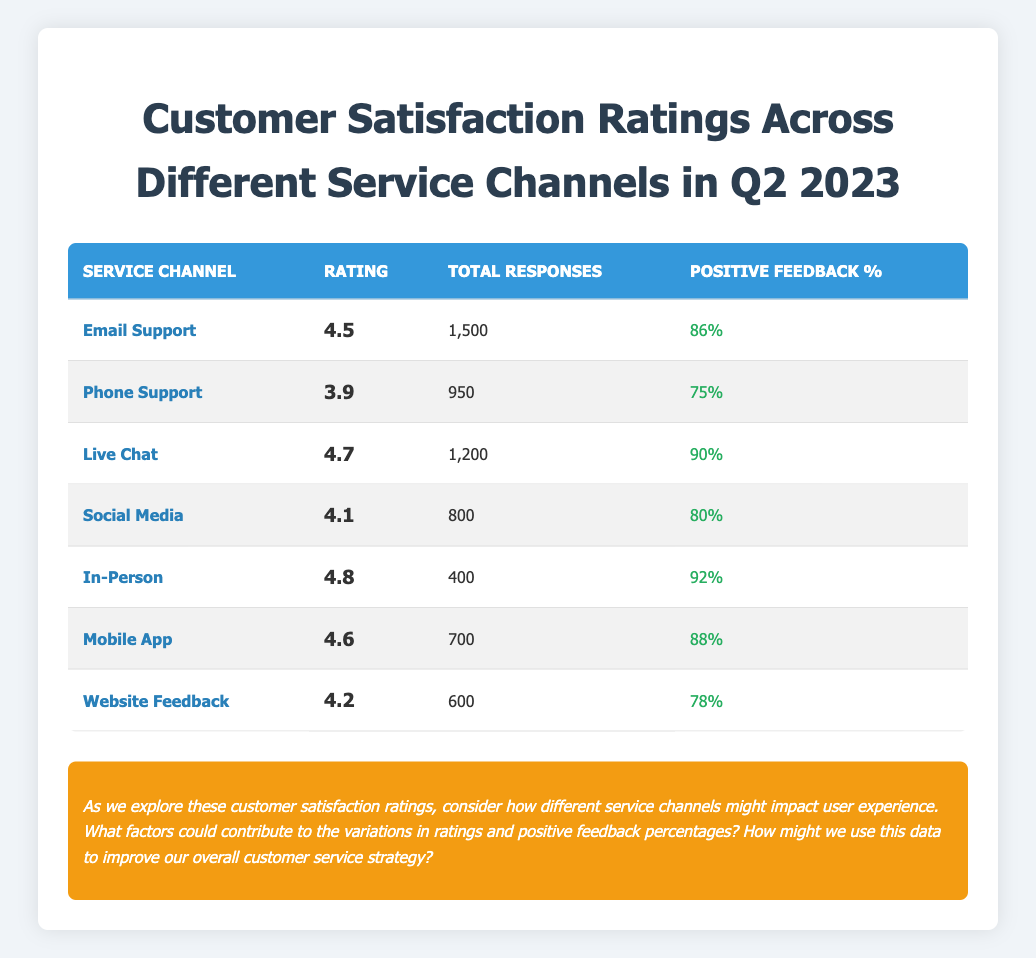What is the highest customer satisfaction rating among the service channels? The service channels and their ratings are listed in the table. The ratings are: 4.5 (Email Support), 3.9 (Phone Support), 4.7 (Live Chat), 4.1 (Social Media), 4.8 (In-Person), 4.6 (Mobile App), and 4.2 (Website Feedback). The highest among these is 4.8 for In-Person.
Answer: 4.8 How many total responses did Live Chat receive? The table shows that Live Chat had a total of 1,200 responses listed under the corresponding column.
Answer: 1,200 Which service channel has the lowest positive feedback percentage? The table shows the positive feedback percentages for each channel: 86% (Email Support), 75% (Phone Support), 90% (Live Chat), 80% (Social Media), 92% (In-Person), 88% (Mobile App), and 78% (Website Feedback). The lowest is 75% for Phone Support.
Answer: Phone Support What is the average rating for all service channels combined? To find the average rating, we sum the ratings (4.5 + 3.9 + 4.7 + 4.1 + 4.8 + 4.6 + 4.2 = 30.8) and divide by the number of channels (7). Thus, 30.8 / 7 = 4.4.
Answer: 4.4 True or False: The Mobile App has a higher positive feedback percentage than the Website Feedback. Mobile App has a positive feedback percentage of 88%, while Website Feedback shows 78% in the table. Since 88% is greater than 78%, the statement is true.
Answer: True What is the difference in positive feedback percentage between In-Person and Social Media services? In-Person has a percentage of 92%, and Social Media has 80%. The difference calculated is 92% - 80% = 12%.
Answer: 12% Which service channel received more than 1,000 total responses? From the table, the channels with responses above 1,000 are: Email Support (1,500) and Live Chat (1,200). Other channels have fewer responses.
Answer: Email Support and Live Chat If we were to categorize the service channels into 'Above Average' and 'Below Average' based on the overall rating average of 4.4, which channels would fall into each category? The ratings above 4.4 are: Live Chat (4.7), In-Person (4.8), and Mobile App (4.6). The below-average ratings are Email Support (4.5), Phone Support (3.9), Social Media (4.1), and Website Feedback (4.2). Hence, Above Average: Live Chat, In-Person, Mobile App; Below Average: Email Support, Phone Support, Social Media, Website Feedback.
Answer: Above Average: Live Chat, In-Person, Mobile App; Below Average: Email Support, Phone Support, Social Media, Website Feedback What percentage of total responses were received by the Phone Support service channel relative to the total responses across all channels? The total responses sum: 1,500 + 950 + 1,200 + 800 + 400 + 700 + 600 = 5,100. Phone Support had 950 responses. The percentage is calculated as (950 / 5100) * 100 = 18.63%.
Answer: 18.63% 